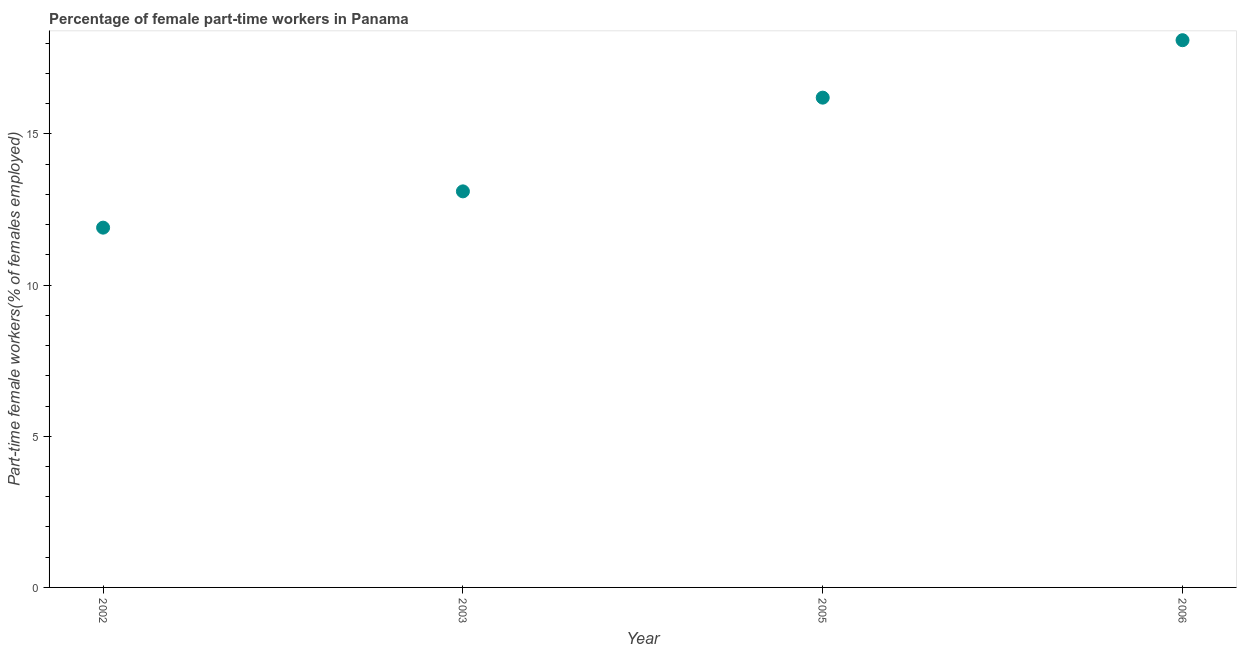What is the percentage of part-time female workers in 2006?
Your answer should be compact. 18.1. Across all years, what is the maximum percentage of part-time female workers?
Your answer should be compact. 18.1. Across all years, what is the minimum percentage of part-time female workers?
Provide a short and direct response. 11.9. What is the sum of the percentage of part-time female workers?
Your answer should be compact. 59.3. What is the difference between the percentage of part-time female workers in 2002 and 2005?
Keep it short and to the point. -4.3. What is the average percentage of part-time female workers per year?
Provide a succinct answer. 14.83. What is the median percentage of part-time female workers?
Provide a succinct answer. 14.65. Do a majority of the years between 2003 and 2002 (inclusive) have percentage of part-time female workers greater than 3 %?
Your answer should be compact. No. What is the ratio of the percentage of part-time female workers in 2002 to that in 2005?
Your answer should be compact. 0.73. Is the difference between the percentage of part-time female workers in 2002 and 2006 greater than the difference between any two years?
Your answer should be very brief. Yes. What is the difference between the highest and the second highest percentage of part-time female workers?
Your answer should be compact. 1.9. What is the difference between the highest and the lowest percentage of part-time female workers?
Provide a succinct answer. 6.2. In how many years, is the percentage of part-time female workers greater than the average percentage of part-time female workers taken over all years?
Keep it short and to the point. 2. How many years are there in the graph?
Ensure brevity in your answer.  4. What is the title of the graph?
Offer a very short reply. Percentage of female part-time workers in Panama. What is the label or title of the X-axis?
Provide a short and direct response. Year. What is the label or title of the Y-axis?
Keep it short and to the point. Part-time female workers(% of females employed). What is the Part-time female workers(% of females employed) in 2002?
Offer a very short reply. 11.9. What is the Part-time female workers(% of females employed) in 2003?
Give a very brief answer. 13.1. What is the Part-time female workers(% of females employed) in 2005?
Your response must be concise. 16.2. What is the Part-time female workers(% of females employed) in 2006?
Your answer should be very brief. 18.1. What is the difference between the Part-time female workers(% of females employed) in 2002 and 2005?
Ensure brevity in your answer.  -4.3. What is the difference between the Part-time female workers(% of females employed) in 2002 and 2006?
Your response must be concise. -6.2. What is the difference between the Part-time female workers(% of females employed) in 2003 and 2005?
Provide a short and direct response. -3.1. What is the difference between the Part-time female workers(% of females employed) in 2003 and 2006?
Offer a very short reply. -5. What is the ratio of the Part-time female workers(% of females employed) in 2002 to that in 2003?
Your answer should be compact. 0.91. What is the ratio of the Part-time female workers(% of females employed) in 2002 to that in 2005?
Your answer should be very brief. 0.73. What is the ratio of the Part-time female workers(% of females employed) in 2002 to that in 2006?
Provide a succinct answer. 0.66. What is the ratio of the Part-time female workers(% of females employed) in 2003 to that in 2005?
Ensure brevity in your answer.  0.81. What is the ratio of the Part-time female workers(% of females employed) in 2003 to that in 2006?
Make the answer very short. 0.72. What is the ratio of the Part-time female workers(% of females employed) in 2005 to that in 2006?
Offer a terse response. 0.9. 